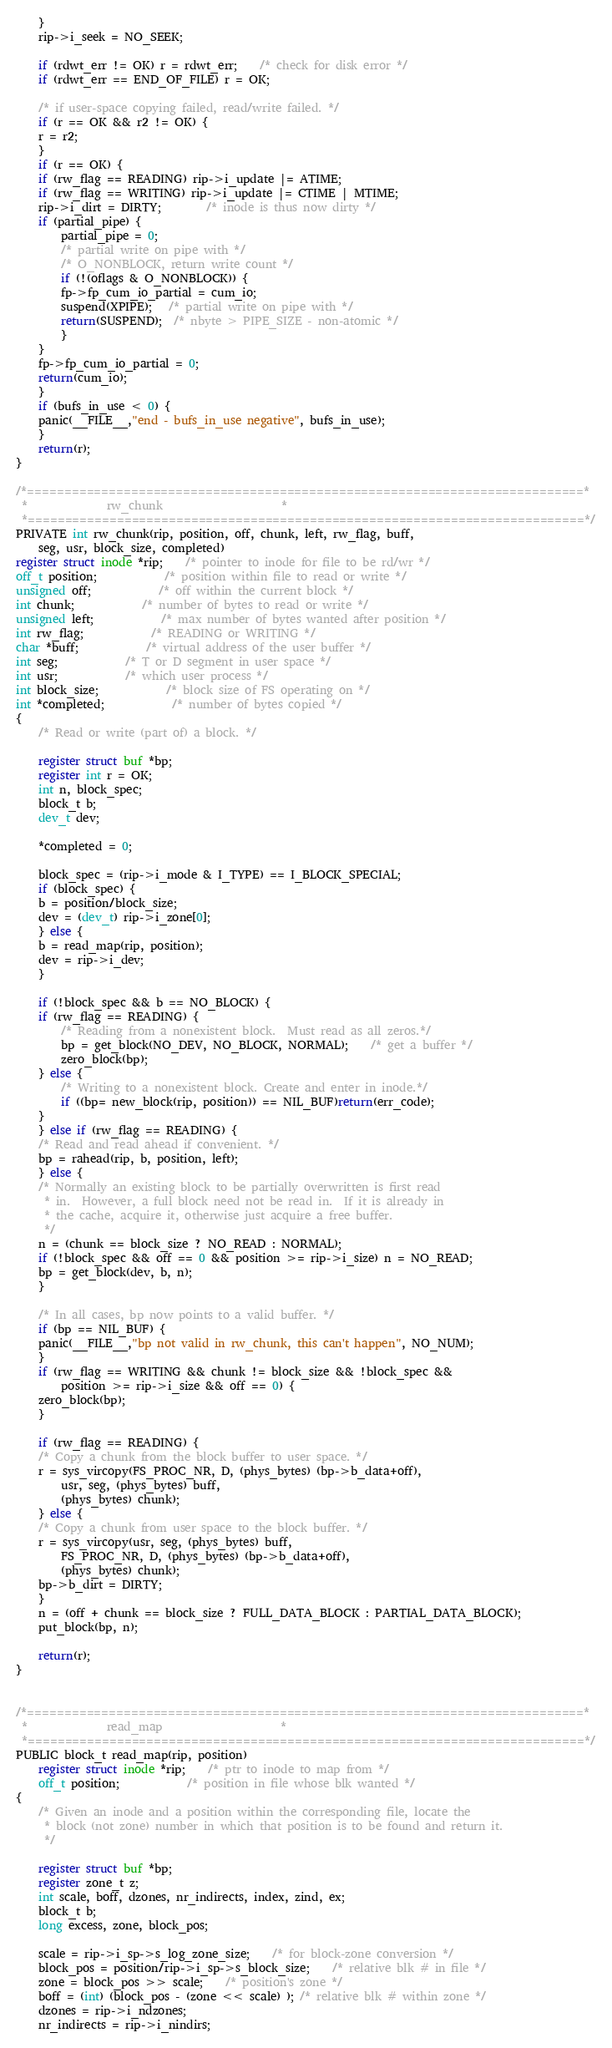<code> <loc_0><loc_0><loc_500><loc_500><_C_>    }
    rip->i_seek = NO_SEEK;

    if (rdwt_err != OK) r = rdwt_err;	/* check for disk error */
    if (rdwt_err == END_OF_FILE) r = OK;

    /* if user-space copying failed, read/write failed. */
    if (r == OK && r2 != OK) {
	r = r2;
    }
    if (r == OK) {
	if (rw_flag == READING) rip->i_update |= ATIME;
	if (rw_flag == WRITING) rip->i_update |= CTIME | MTIME;
	rip->i_dirt = DIRTY;		/* inode is thus now dirty */
	if (partial_pipe) {
	    partial_pipe = 0;
	    /* partial write on pipe with */
	    /* O_NONBLOCK, return write count */
	    if (!(oflags & O_NONBLOCK)) {
		fp->fp_cum_io_partial = cum_io;
		suspend(XPIPE);   /* partial write on pipe with */
		return(SUSPEND);  /* nbyte > PIPE_SIZE - non-atomic */
	    }
	}
	fp->fp_cum_io_partial = 0;
	return(cum_io);
    }
    if (bufs_in_use < 0) {
	panic(__FILE__,"end - bufs_in_use negative", bufs_in_use);
    }
    return(r);
}

/*===========================================================================*
 *				rw_chunk				     *
 *===========================================================================*/
PRIVATE int rw_chunk(rip, position, off, chunk, left, rw_flag, buff,
	seg, usr, block_size, completed)
register struct inode *rip;	/* pointer to inode for file to be rd/wr */
off_t position;			/* position within file to read or write */
unsigned off;			/* off within the current block */
int chunk;			/* number of bytes to read or write */
unsigned left;			/* max number of bytes wanted after position */
int rw_flag;			/* READING or WRITING */
char *buff;			/* virtual address of the user buffer */
int seg;			/* T or D segment in user space */
int usr;			/* which user process */
int block_size;			/* block size of FS operating on */
int *completed;			/* number of bytes copied */
{
    /* Read or write (part of) a block. */

    register struct buf *bp;
    register int r = OK;
    int n, block_spec;
    block_t b;
    dev_t dev;

    *completed = 0;

    block_spec = (rip->i_mode & I_TYPE) == I_BLOCK_SPECIAL;
    if (block_spec) {
	b = position/block_size;
	dev = (dev_t) rip->i_zone[0];
    } else {
	b = read_map(rip, position);
	dev = rip->i_dev;
    }

    if (!block_spec && b == NO_BLOCK) {
	if (rw_flag == READING) {
	    /* Reading from a nonexistent block.  Must read as all zeros.*/
	    bp = get_block(NO_DEV, NO_BLOCK, NORMAL);    /* get a buffer */
	    zero_block(bp);
	} else {
	    /* Writing to a nonexistent block. Create and enter in inode.*/
	    if ((bp= new_block(rip, position)) == NIL_BUF)return(err_code);
	}
    } else if (rw_flag == READING) {
	/* Read and read ahead if convenient. */
	bp = rahead(rip, b, position, left);
    } else {
	/* Normally an existing block to be partially overwritten is first read
	 * in.  However, a full block need not be read in.  If it is already in
	 * the cache, acquire it, otherwise just acquire a free buffer.
	 */
	n = (chunk == block_size ? NO_READ : NORMAL);
	if (!block_spec && off == 0 && position >= rip->i_size) n = NO_READ;
	bp = get_block(dev, b, n);
    }

    /* In all cases, bp now points to a valid buffer. */
    if (bp == NIL_BUF) {
	panic(__FILE__,"bp not valid in rw_chunk, this can't happen", NO_NUM);
    }
    if (rw_flag == WRITING && chunk != block_size && !block_spec &&
	    position >= rip->i_size && off == 0) {
	zero_block(bp);
    }

    if (rw_flag == READING) {
	/* Copy a chunk from the block buffer to user space. */
	r = sys_vircopy(FS_PROC_NR, D, (phys_bytes) (bp->b_data+off),
		usr, seg, (phys_bytes) buff,
		(phys_bytes) chunk);
    } else {
	/* Copy a chunk from user space to the block buffer. */
	r = sys_vircopy(usr, seg, (phys_bytes) buff,
		FS_PROC_NR, D, (phys_bytes) (bp->b_data+off),
		(phys_bytes) chunk);
	bp->b_dirt = DIRTY;
    }
    n = (off + chunk == block_size ? FULL_DATA_BLOCK : PARTIAL_DATA_BLOCK);
    put_block(bp, n);

    return(r);
}


/*===========================================================================*
 *				read_map				     *
 *===========================================================================*/
PUBLIC block_t read_map(rip, position)
    register struct inode *rip;	/* ptr to inode to map from */
    off_t position;			/* position in file whose blk wanted */
{
    /* Given an inode and a position within the corresponding file, locate the
     * block (not zone) number in which that position is to be found and return it.
     */

    register struct buf *bp;
    register zone_t z;
    int scale, boff, dzones, nr_indirects, index, zind, ex;
    block_t b;
    long excess, zone, block_pos;

    scale = rip->i_sp->s_log_zone_size;	/* for block-zone conversion */
    block_pos = position/rip->i_sp->s_block_size;	/* relative blk # in file */
    zone = block_pos >> scale;	/* position's zone */
    boff = (int) (block_pos - (zone << scale) ); /* relative blk # within zone */
    dzones = rip->i_ndzones;
    nr_indirects = rip->i_nindirs;
</code> 